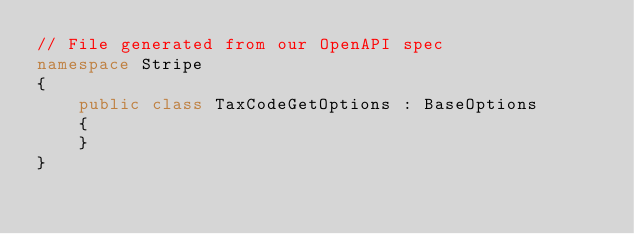<code> <loc_0><loc_0><loc_500><loc_500><_C#_>// File generated from our OpenAPI spec
namespace Stripe
{
    public class TaxCodeGetOptions : BaseOptions
    {
    }
}
</code> 